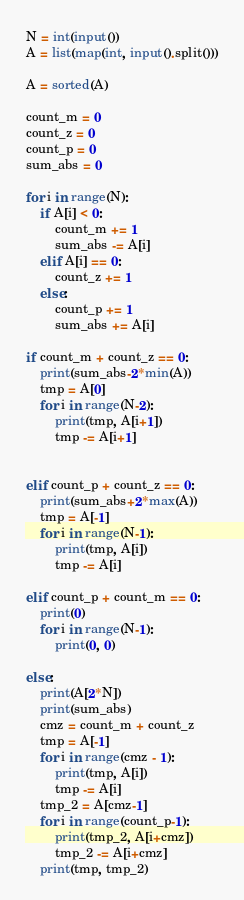Convert code to text. <code><loc_0><loc_0><loc_500><loc_500><_Python_>N = int(input())
A = list(map(int, input().split()))

A = sorted(A)

count_m = 0
count_z = 0
count_p = 0
sum_abs = 0

for i in range(N):
    if A[i] < 0:
        count_m += 1
        sum_abs -= A[i]
    elif A[i] == 0:
        count_z += 1
    else:
        count_p += 1
        sum_abs += A[i]

if count_m + count_z == 0:
    print(sum_abs-2*min(A))
    tmp = A[0]
    for i in range(N-2):
        print(tmp, A[i+1])
        tmp -= A[i+1]
    

elif count_p + count_z == 0:
    print(sum_abs+2*max(A))
    tmp = A[-1]
    for i in range(N-1):
        print(tmp, A[i])
        tmp -= A[i]

elif count_p + count_m == 0:
    print(0)
    for i in range(N-1):
        print(0, 0)

else:
    print(A[2*N])
    print(sum_abs)
    cmz = count_m + count_z
    tmp = A[-1]
    for i in range(cmz - 1):
        print(tmp, A[i])
        tmp -= A[i]
    tmp_2 = A[cmz-1]
    for i in range(count_p-1):
        print(tmp_2, A[i+cmz])
        tmp_2 -= A[i+cmz]
    print(tmp, tmp_2)</code> 